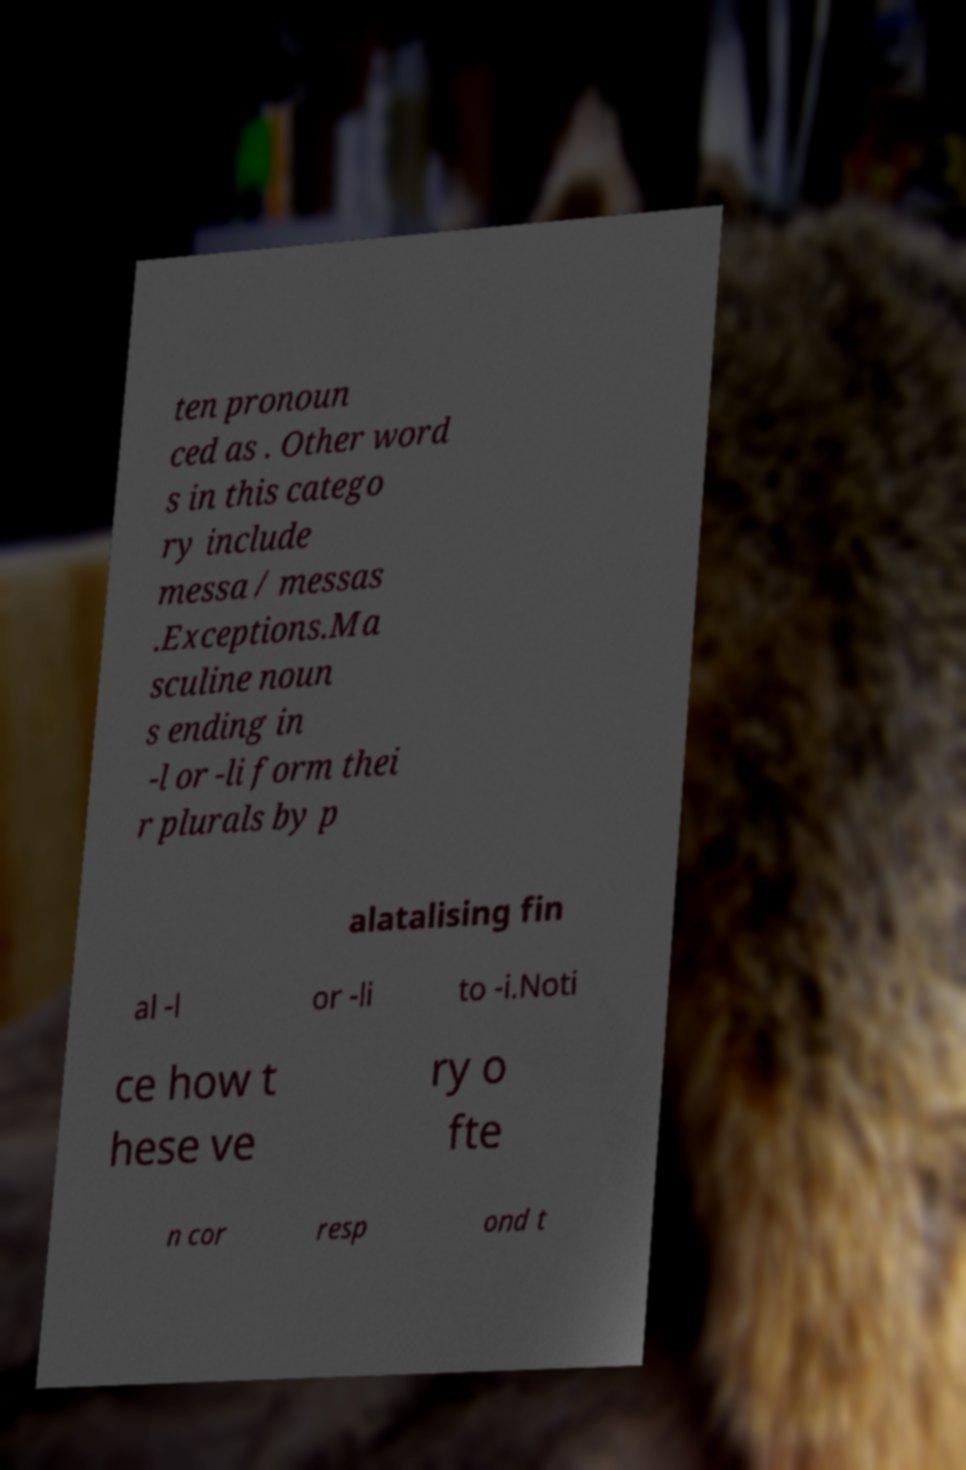Can you read and provide the text displayed in the image?This photo seems to have some interesting text. Can you extract and type it out for me? ten pronoun ced as . Other word s in this catego ry include messa / messas .Exceptions.Ma sculine noun s ending in -l or -li form thei r plurals by p alatalising fin al -l or -li to -i.Noti ce how t hese ve ry o fte n cor resp ond t 